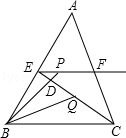How does the concept of angle bisectors help solve problems related to triangles? Angle bisectors in a triangle, such as the one from angle CBP to point Q in this diagram, are crucial for determining proportions and relationships within the triangle. They often lead to finding ratios of sides, as they create similar triangles when they intersect other lines or reach the opposite side. In problems that require calculating distances or ratios within a triangle, the angle bisector can provide a straightforward path to the solution by leveraging properties of similar triangles. 